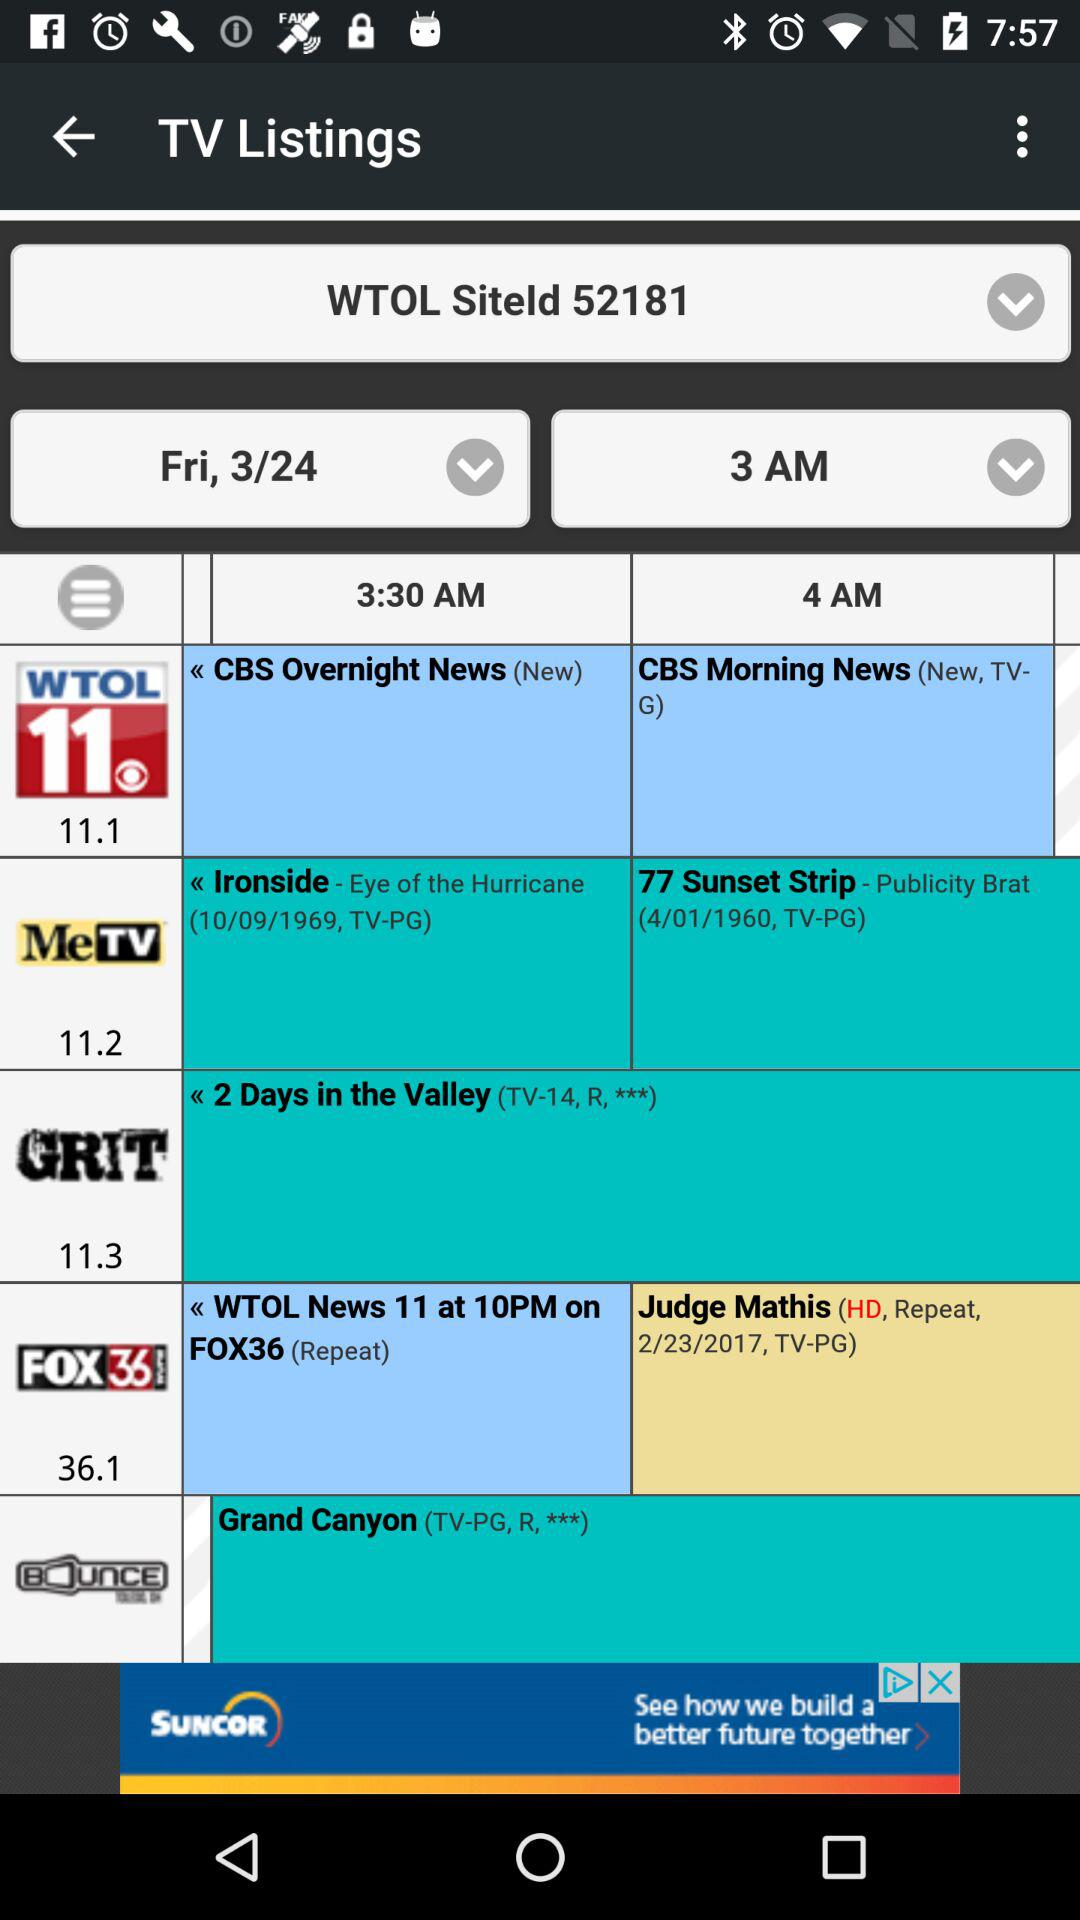What is the time for the "CBS Overnight News"? The time is 3:30 AM. 